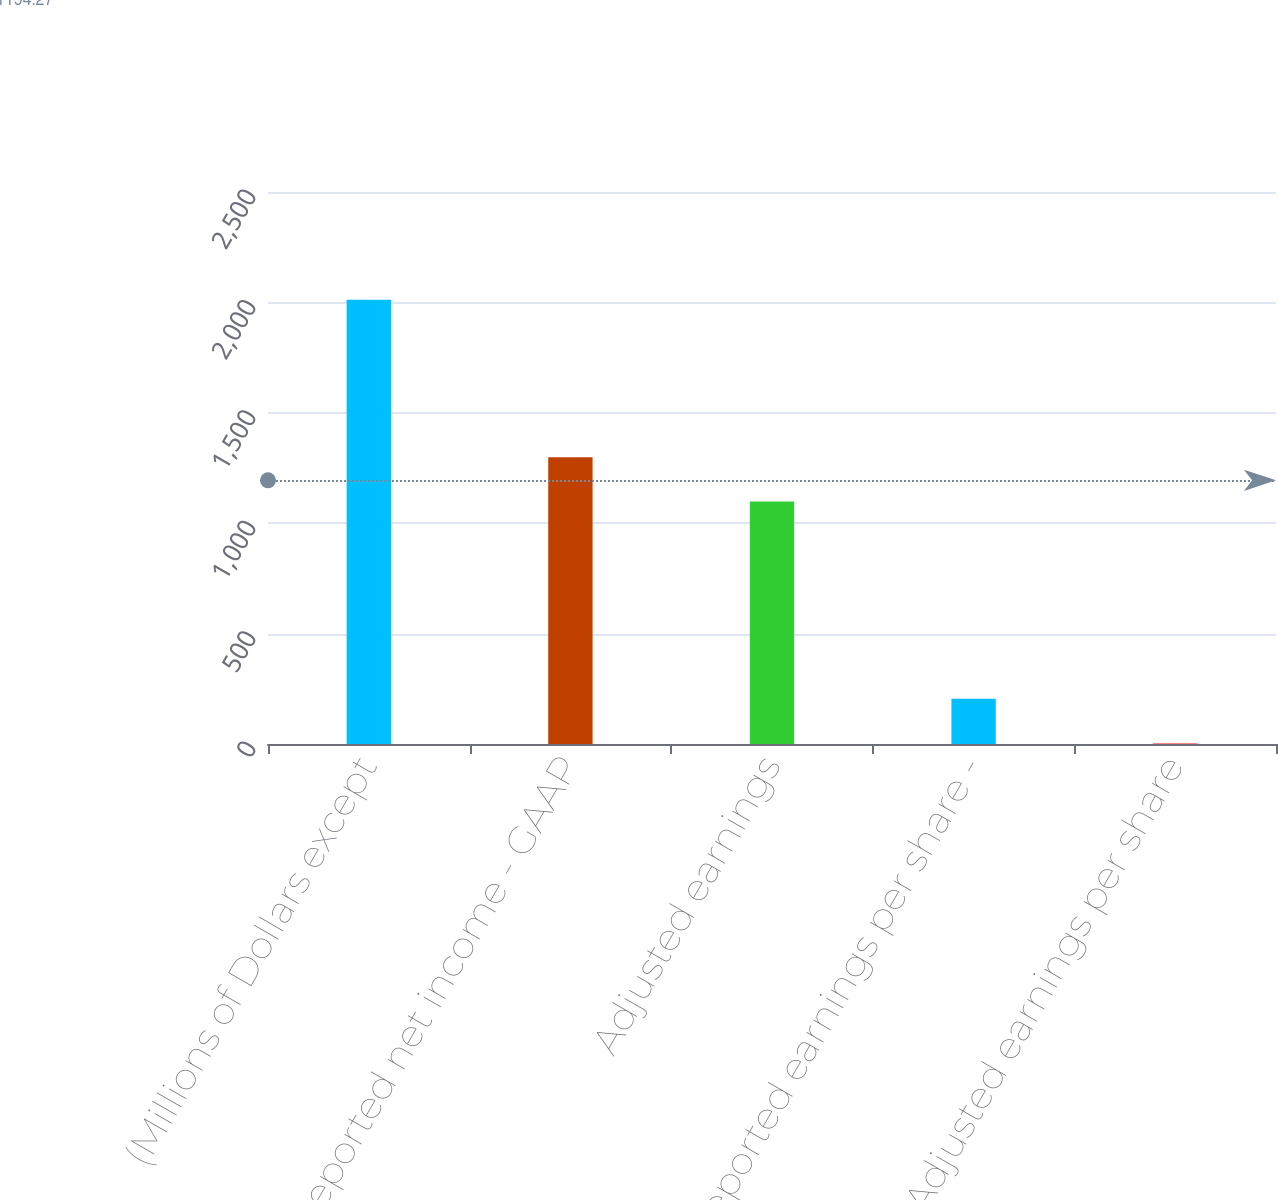<chart> <loc_0><loc_0><loc_500><loc_500><bar_chart><fcel>(Millions of Dollars except<fcel>Reported net income - GAAP<fcel>Adjusted earnings<fcel>Reported earnings per share -<fcel>Adjusted earnings per share<nl><fcel>2012<fcel>1298.83<fcel>1098<fcel>204.58<fcel>3.75<nl></chart> 